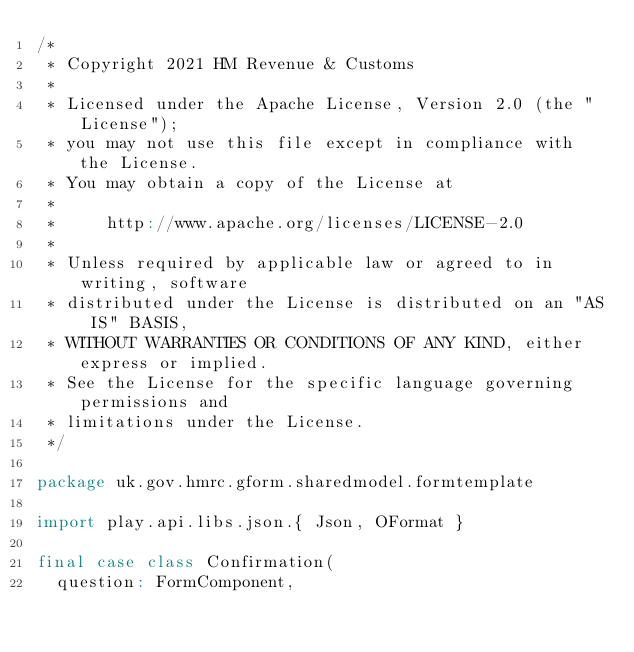Convert code to text. <code><loc_0><loc_0><loc_500><loc_500><_Scala_>/*
 * Copyright 2021 HM Revenue & Customs
 *
 * Licensed under the Apache License, Version 2.0 (the "License");
 * you may not use this file except in compliance with the License.
 * You may obtain a copy of the License at
 *
 *     http://www.apache.org/licenses/LICENSE-2.0
 *
 * Unless required by applicable law or agreed to in writing, software
 * distributed under the License is distributed on an "AS IS" BASIS,
 * WITHOUT WARRANTIES OR CONDITIONS OF ANY KIND, either express or implied.
 * See the License for the specific language governing permissions and
 * limitations under the License.
 */

package uk.gov.hmrc.gform.sharedmodel.formtemplate

import play.api.libs.json.{ Json, OFormat }

final case class Confirmation(
  question: FormComponent,</code> 